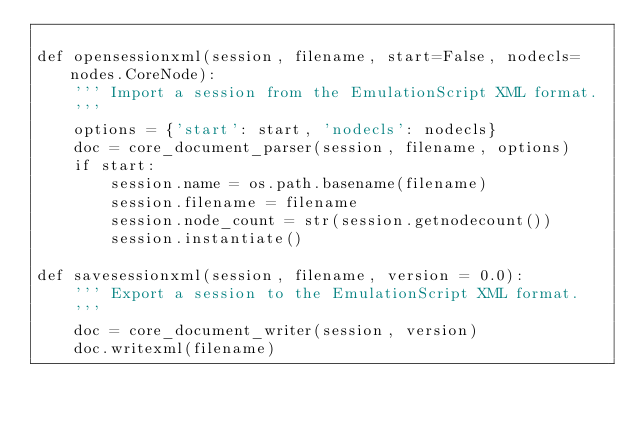Convert code to text. <code><loc_0><loc_0><loc_500><loc_500><_Python_>
def opensessionxml(session, filename, start=False, nodecls=nodes.CoreNode):
    ''' Import a session from the EmulationScript XML format.
    '''
    options = {'start': start, 'nodecls': nodecls}
    doc = core_document_parser(session, filename, options)
    if start:
        session.name = os.path.basename(filename)
        session.filename = filename
        session.node_count = str(session.getnodecount())
        session.instantiate()

def savesessionxml(session, filename, version = 0.0):
    ''' Export a session to the EmulationScript XML format.
    '''
    doc = core_document_writer(session, version)
    doc.writexml(filename)
</code> 